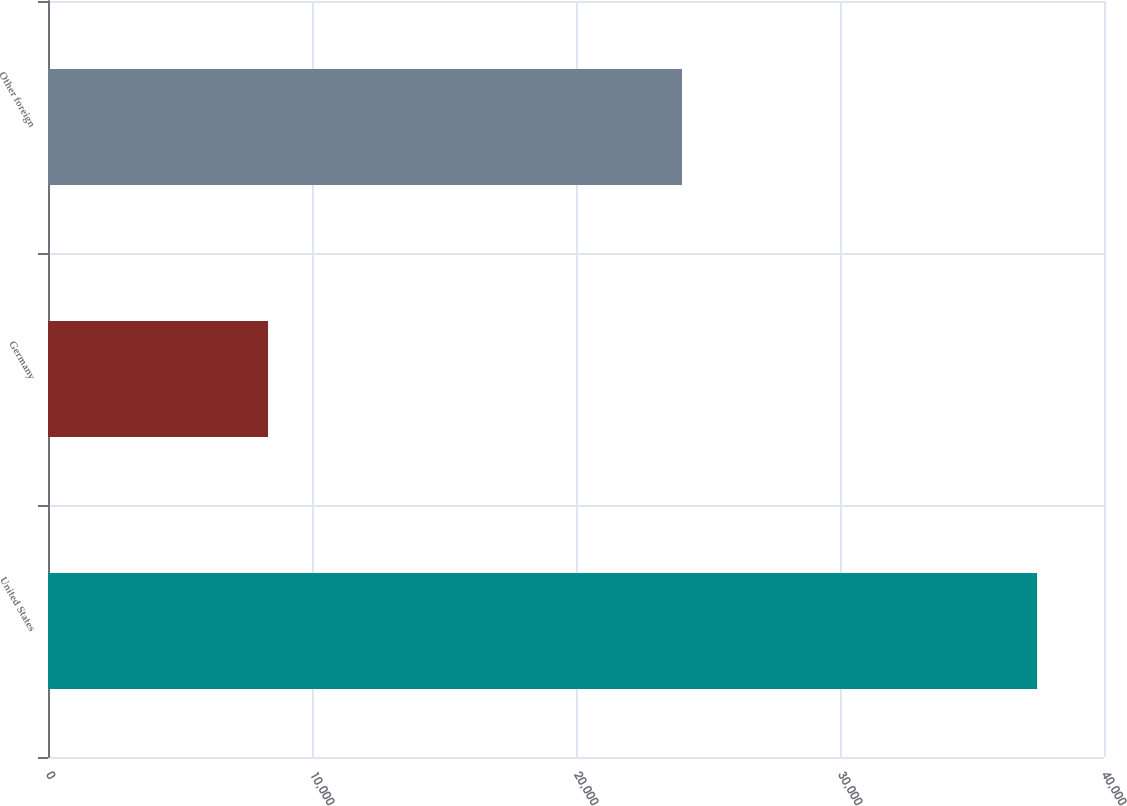<chart> <loc_0><loc_0><loc_500><loc_500><bar_chart><fcel>United States<fcel>Germany<fcel>Other foreign<nl><fcel>37466<fcel>8335<fcel>24015<nl></chart> 